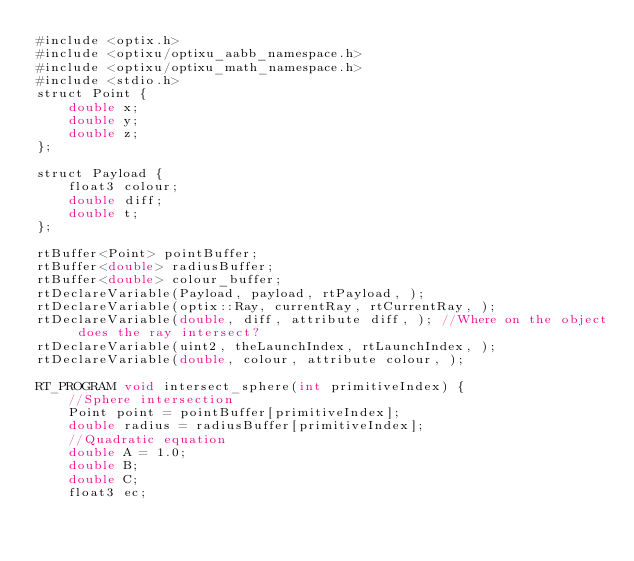Convert code to text. <code><loc_0><loc_0><loc_500><loc_500><_Cuda_>#include <optix.h>
#include <optixu/optixu_aabb_namespace.h>
#include <optixu/optixu_math_namespace.h>
#include <stdio.h>
struct Point {
	double x;
	double y;
	double z;
};

struct Payload {
	float3 colour;
	double diff;
	double t;
};

rtBuffer<Point> pointBuffer;
rtBuffer<double> radiusBuffer;
rtBuffer<double> colour_buffer;
rtDeclareVariable(Payload, payload, rtPayload, );
rtDeclareVariable(optix::Ray, currentRay, rtCurrentRay, );
rtDeclareVariable(double, diff, attribute diff, ); //Where on the object does the ray intersect?
rtDeclareVariable(uint2, theLaunchIndex, rtLaunchIndex, );
rtDeclareVariable(double, colour, attribute colour, );

RT_PROGRAM void intersect_sphere(int primitiveIndex) {
	//Sphere intersection
	Point point = pointBuffer[primitiveIndex];
	double radius = radiusBuffer[primitiveIndex];
	//Quadratic equation
	double A = 1.0;
	double B;
	double C;
	float3 ec;</code> 